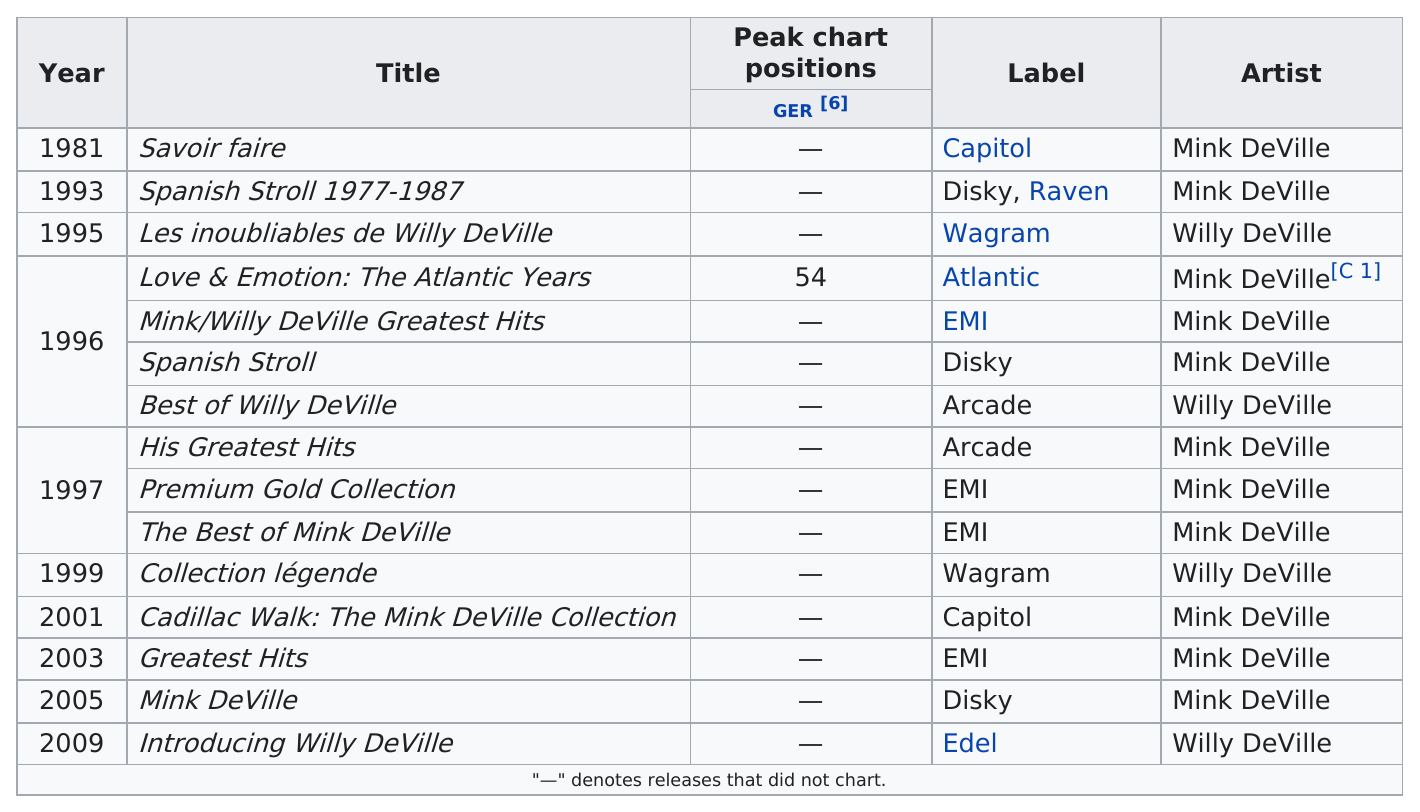Give some essential details in this illustration. The total number of albums released by Willy DeVille is 4. In 1997, they released three compilation albums. The album by Willy DeVille that was released after 'Savoir Faire' is titled 'Les Inoubliables de Willy DeVille'. It is not known how many Willy DeVille albums have reached the charts. The first compilation album was released in the year 1981. 